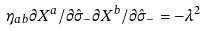<formula> <loc_0><loc_0><loc_500><loc_500>\eta _ { a b } \partial X ^ { a } / \partial \hat { \sigma } _ { - } \partial X ^ { b } / \partial \hat { \sigma } _ { - } = - \lambda ^ { 2 }</formula> 